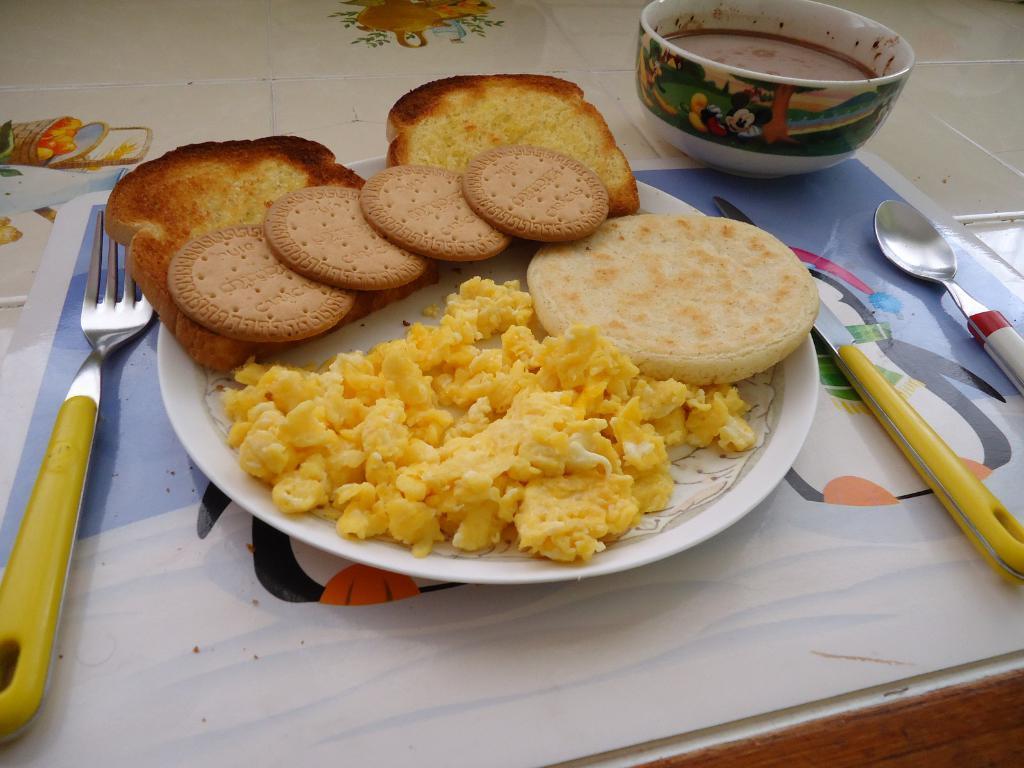Please provide a concise description of this image. In the picture I can see food items on a plate. I can also see a spoon, a knife, a fork, a bowl and some other objects. 